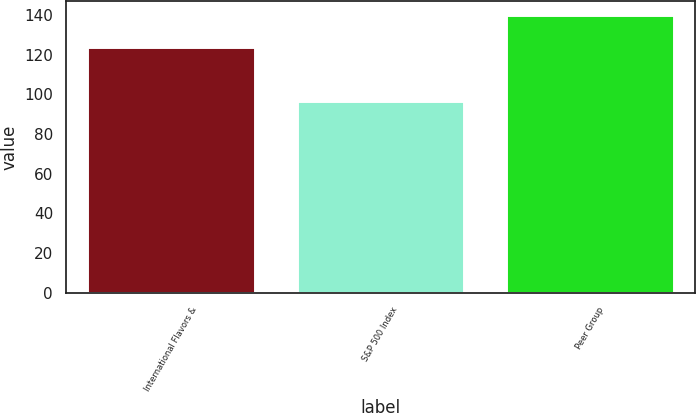<chart> <loc_0><loc_0><loc_500><loc_500><bar_chart><fcel>International Flavors &<fcel>S&P 500 Index<fcel>Peer Group<nl><fcel>124.13<fcel>96.71<fcel>139.89<nl></chart> 